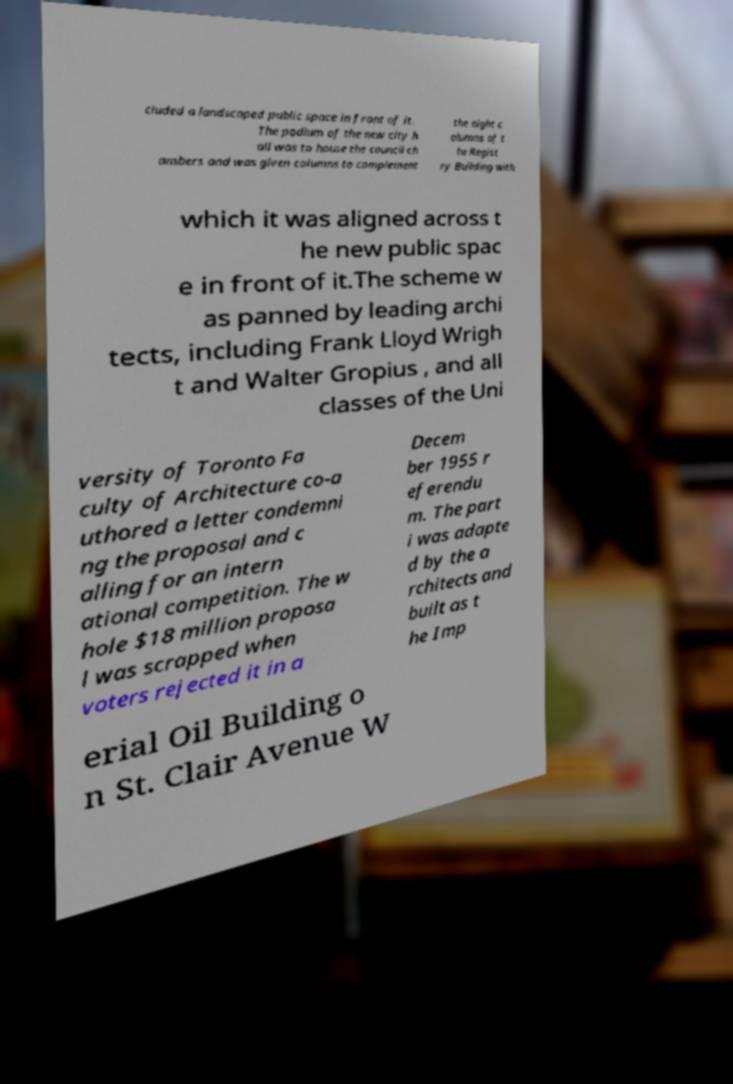Please identify and transcribe the text found in this image. cluded a landscaped public space in front of it. The podium of the new city h all was to house the council ch ambers and was given columns to complement the eight c olumns of t he Regist ry Building with which it was aligned across t he new public spac e in front of it.The scheme w as panned by leading archi tects, including Frank Lloyd Wrigh t and Walter Gropius , and all classes of the Uni versity of Toronto Fa culty of Architecture co-a uthored a letter condemni ng the proposal and c alling for an intern ational competition. The w hole $18 million proposa l was scrapped when voters rejected it in a Decem ber 1955 r eferendu m. The part i was adapte d by the a rchitects and built as t he Imp erial Oil Building o n St. Clair Avenue W 